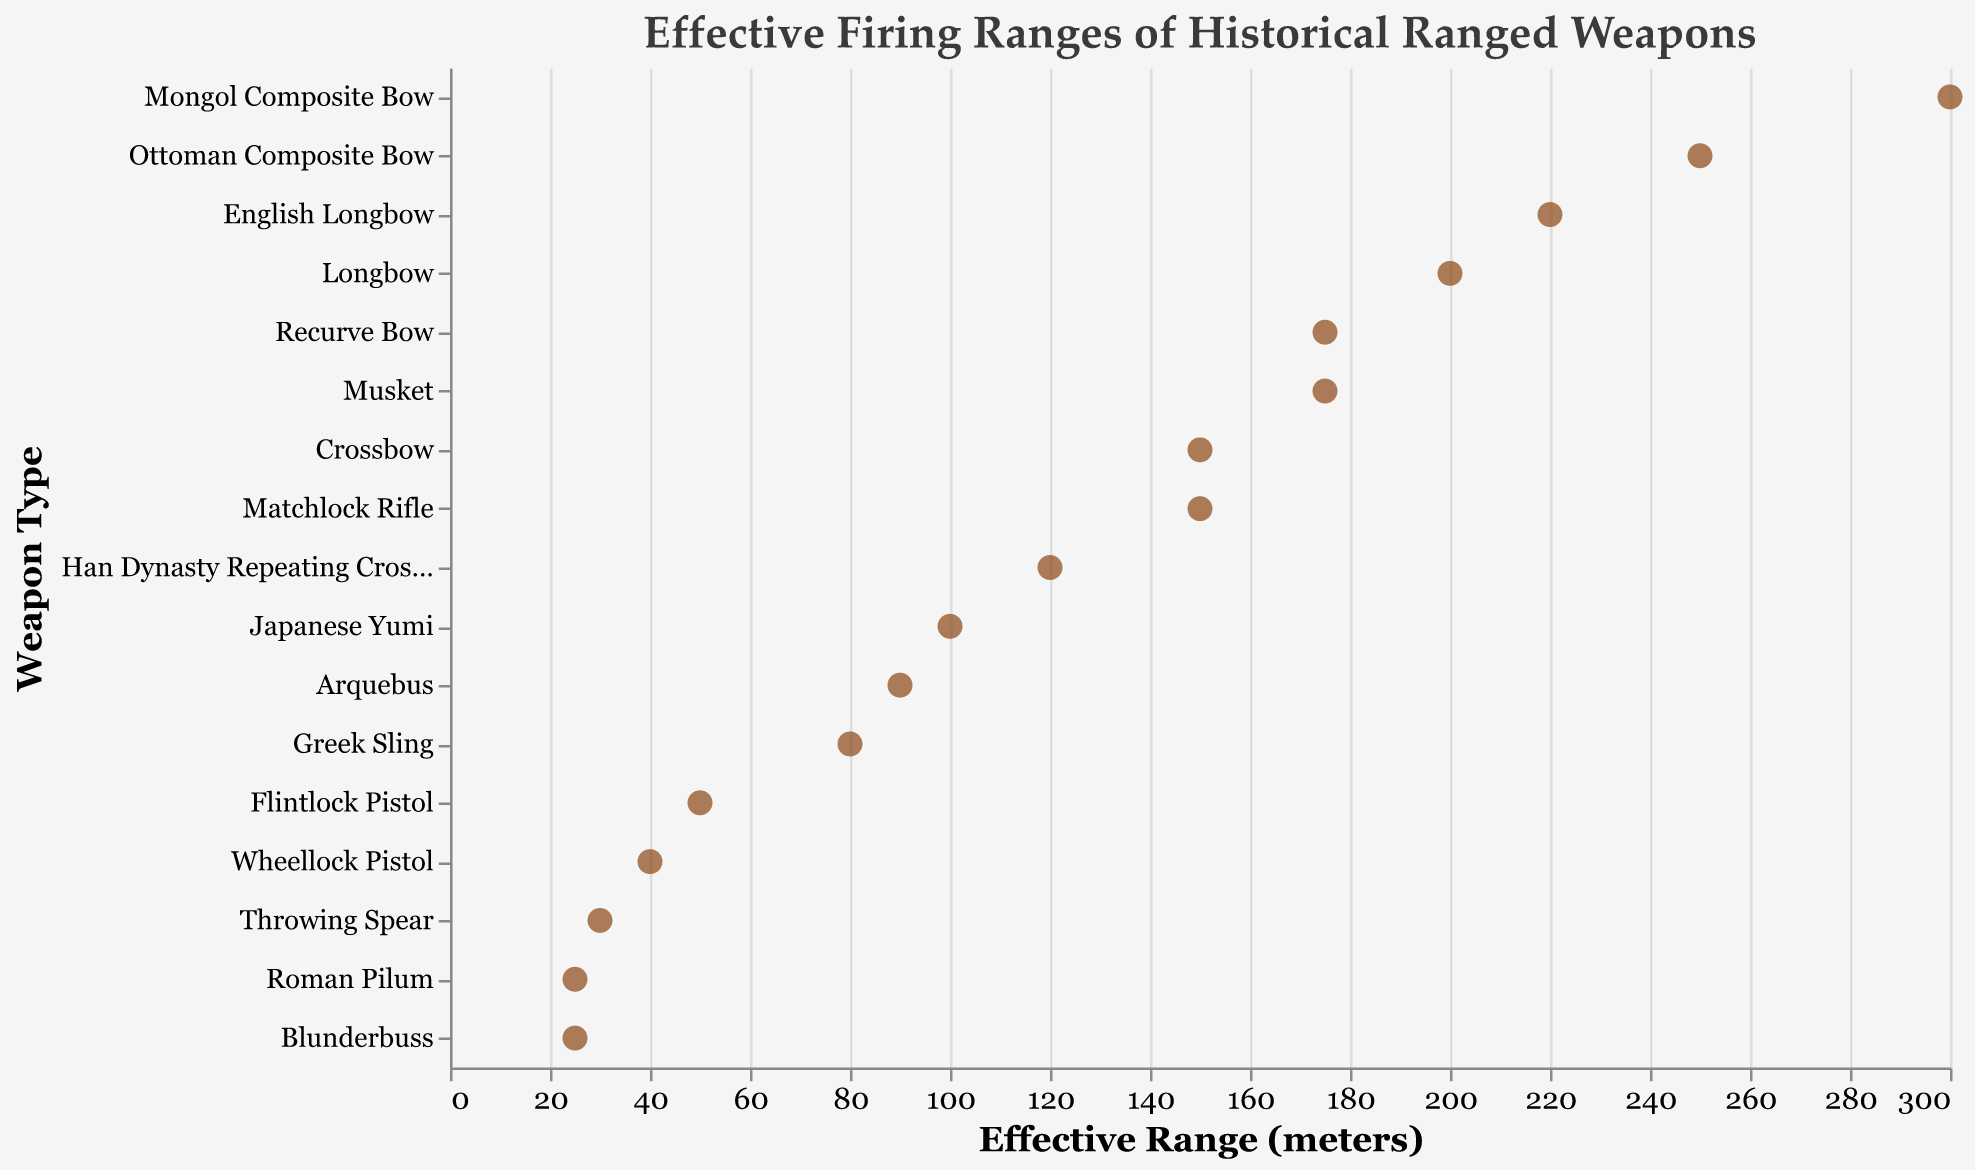What's the title of the figure? The title of the figure is generally located at the top center and is intended to provide a quick understanding of what the figure depicts.
Answer: Effective Firing Ranges of Historical Ranged Weapons How many different weapon types are shown in the figure? To find the number of different weapon types, you count the distinct labels along the y-axis.
Answer: 17 Which weapon has the shortest effective range? Look for the data point that is plotted the farthest to the left along the x-axis. The corresponding label on the y-axis will give you the weapon type.
Answer: Roman Pilum Which weapon has the longest effective range? Look for the data point plotted the farthest to the right along the x-axis, and check the corresponding label on the y-axis.
Answer: Mongol Composite Bow How does the effective range of the Flintlock Pistol compare to that of the Matchlock Rifle? Locate both the Flintlock Pistol and Matchlock Rifle on the y-axis. Compare where their respective points fall along the x-axis. The Flintlock Pistol has a range of 50 meters, and the Matchlock Rifle has a range of 150 meters.
Answer: The Flintlock Pistol has a shorter range than the Matchlock Rifle What is the range difference between the Longbow and the Crossbow? Find the effective ranges of both the Longbow (200 meters) and the Crossbow (150 meters). Subtract the Crossbow's range from the Longbow's range.
Answer: 50 meters What is the combined effective range of the Greek Sling and the Japanese Yumi? Find the effective ranges of the Greek Sling (80 meters) and the Japanese Yumi (100 meters). Add these values together.
Answer: 180 meters Which weapon types have exactly the same effective range? Scan the data points to find any points that are plotted directly above or below one another along the same x-axis value. Both the Crossbow and the Matchlock Rifle have ranges of 150 meters, and both the Recurve Bow and Musket have ranges of 175 meters.
Answer: Crossbow & Matchlock Rifle, Recurve Bow & Musket Are there more bow-type weapons (e.g., Longbow, Crossbow) or early firearms (e.g., Arquebus, Musket) in the data set? Count the number of bow-type weapons and the number of early firearms from the list. There are 7 bow-type weapons (Longbow, Crossbow, Recurve Bow, English Longbow, Japanese Yumi, Mongol Composite Bow, Ottoman Composite Bow) and 6 early firearms (Arquebus, Musket, Flintlock Pistol, Blunderbuss, Wheellock Pistol, Matchlock Rifle).
Answer: More bow-type weapons What is the average effective range of all the weapons listed? To find the average, sum up all the effective ranges and divide by the number of weapon types. Sum = 200 + 150 + 175 + 220 + 100 + 90 + 175 + 50 + 30 + 25 + 80 + 300 + 250 + 120 + 25 + 40 + 150 = 2180. Total number of weapons = 17. Average = 2180 / 17 = approximately 128.2 meters.
Answer: Approximately 128.2 meters 